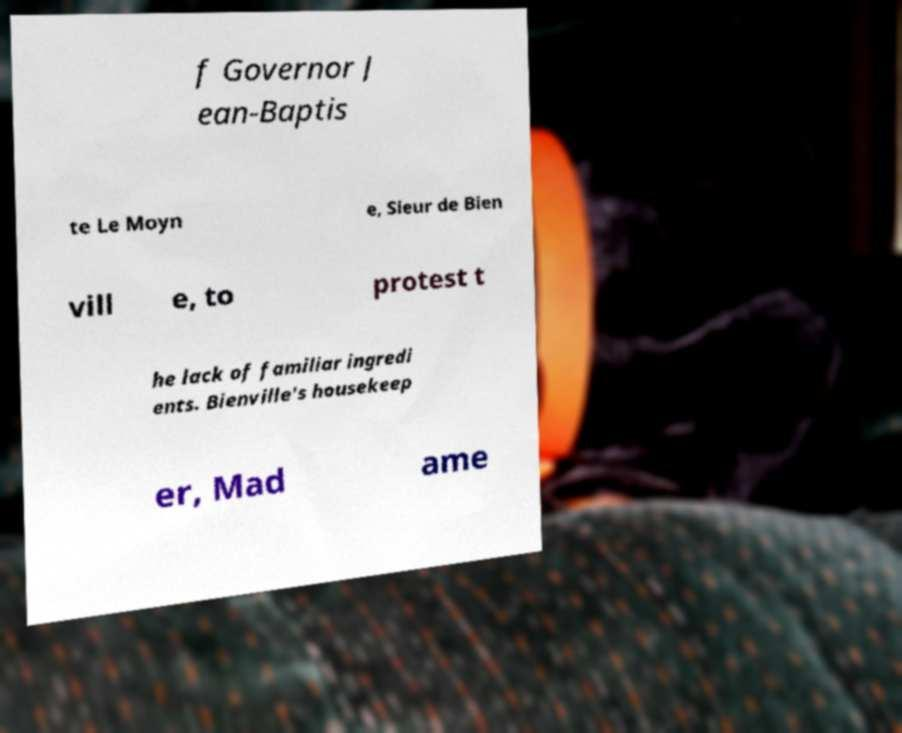There's text embedded in this image that I need extracted. Can you transcribe it verbatim? f Governor J ean-Baptis te Le Moyn e, Sieur de Bien vill e, to protest t he lack of familiar ingredi ents. Bienville's housekeep er, Mad ame 